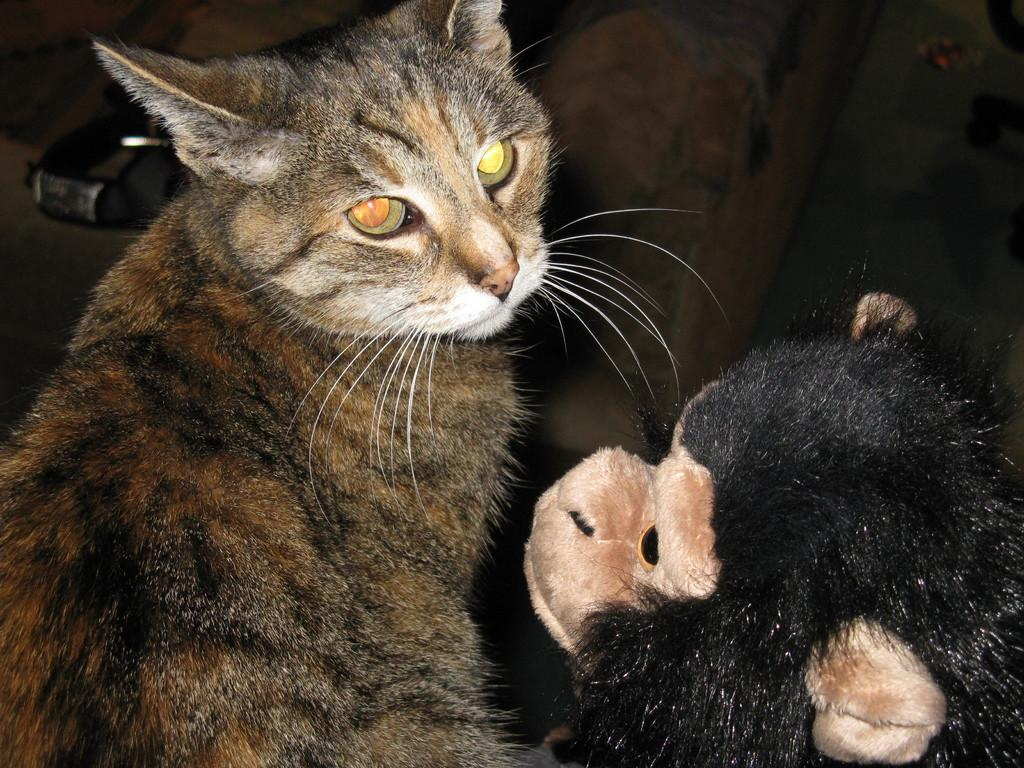What type of animal is present in the image? There is a cat in the image. What other object can be seen in the image? There is a toy monkey in the image. What type of clouds can be seen in the image? There are no clouds present in the image; it features a cat and a toy monkey. What type of meal is being prepared in the image? There is no meal preparation visible in the image. What type of songs can be heard playing in the background of the image? There is no music or songs present in the image. 